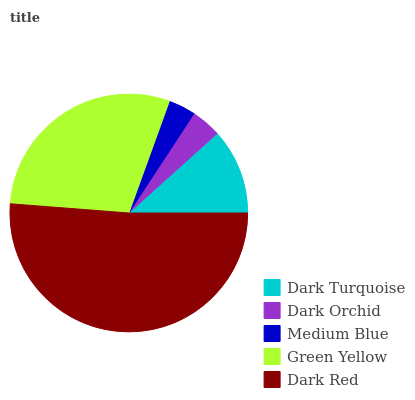Is Medium Blue the minimum?
Answer yes or no. Yes. Is Dark Red the maximum?
Answer yes or no. Yes. Is Dark Orchid the minimum?
Answer yes or no. No. Is Dark Orchid the maximum?
Answer yes or no. No. Is Dark Turquoise greater than Dark Orchid?
Answer yes or no. Yes. Is Dark Orchid less than Dark Turquoise?
Answer yes or no. Yes. Is Dark Orchid greater than Dark Turquoise?
Answer yes or no. No. Is Dark Turquoise less than Dark Orchid?
Answer yes or no. No. Is Dark Turquoise the high median?
Answer yes or no. Yes. Is Dark Turquoise the low median?
Answer yes or no. Yes. Is Dark Red the high median?
Answer yes or no. No. Is Dark Orchid the low median?
Answer yes or no. No. 